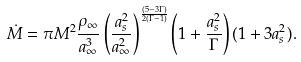<formula> <loc_0><loc_0><loc_500><loc_500>\dot { M } = { \pi } M ^ { 2 } \frac { \rho _ { \infty } } { a _ { \infty } ^ { 3 } } \left ( \frac { a _ { s } ^ { 2 } } { a _ { \infty } ^ { 2 } } \right ) ^ { \frac { ( 5 - 3 \Gamma ) } { 2 ( \Gamma - 1 ) } } \left ( 1 + \frac { a _ { s } ^ { 2 } } { \Gamma } \right ) ( 1 + 3 a _ { s } ^ { 2 } ) .</formula> 